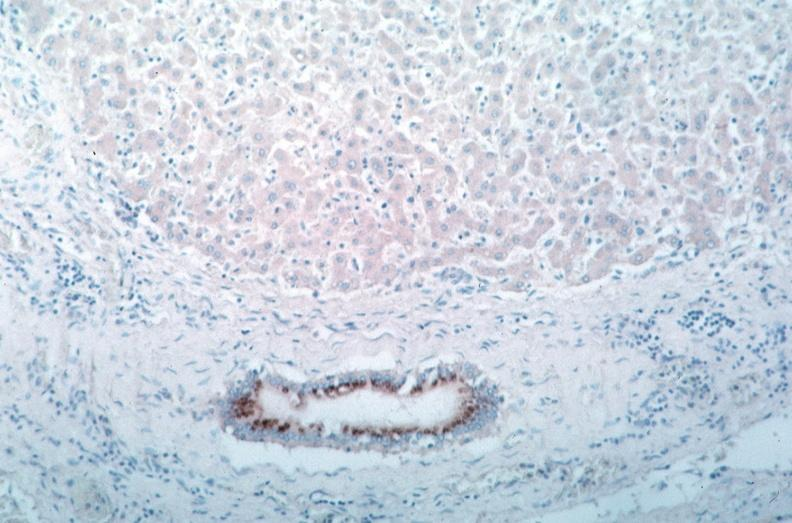does this image show vasculitis?
Answer the question using a single word or phrase. Yes 